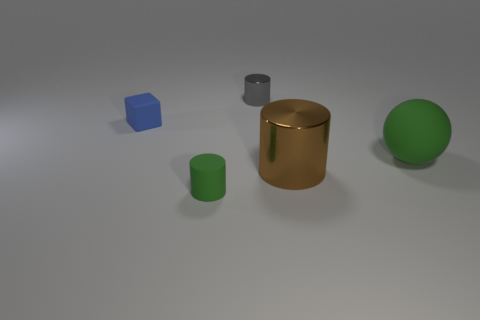If I were to group the objects by their material properties, how would they be categorized? The objects could be grouped into two categories based on their appearance. One category would be 'metallic' for the large cylinder that has a shiny, reflective surface. The other category would be 'matte' for the blue cube, green cylinder, and green sphere, all of which have non-reflective surfaces. 